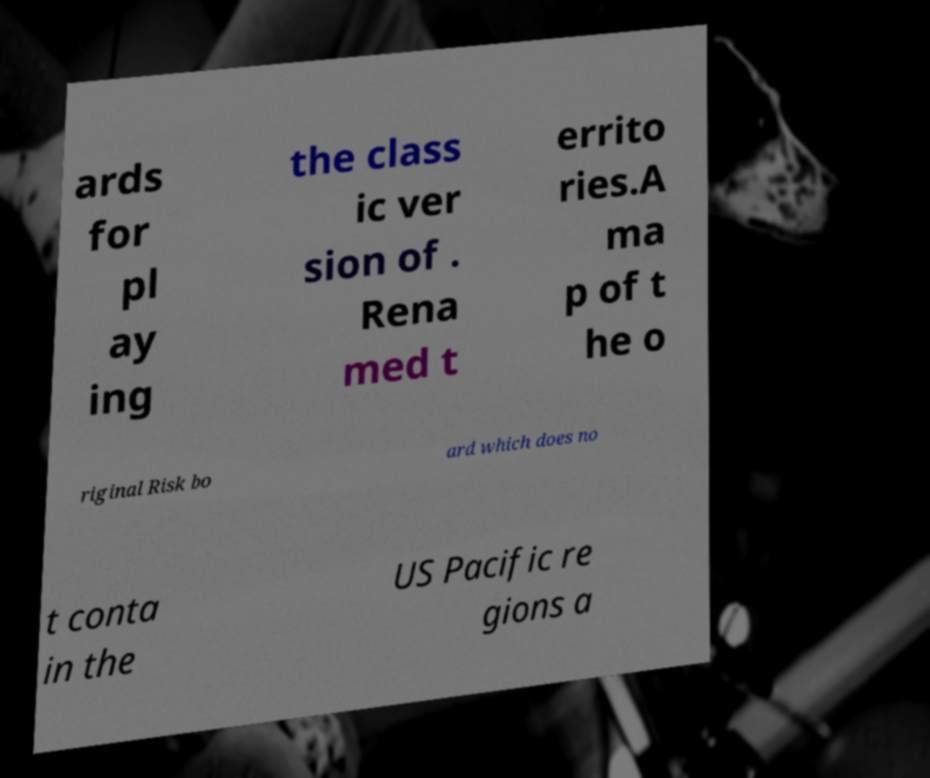Could you extract and type out the text from this image? ards for pl ay ing the class ic ver sion of . Rena med t errito ries.A ma p of t he o riginal Risk bo ard which does no t conta in the US Pacific re gions a 